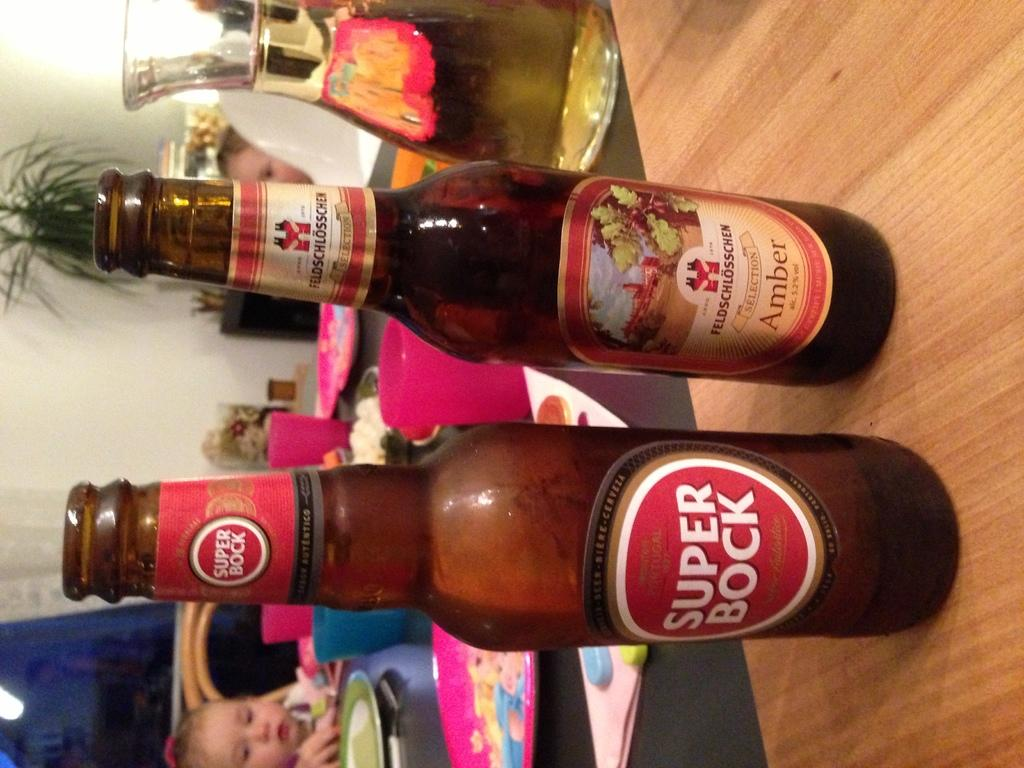<image>
Create a compact narrative representing the image presented. Two bottles of beer including one named Super Bock stand side by side on a table. 